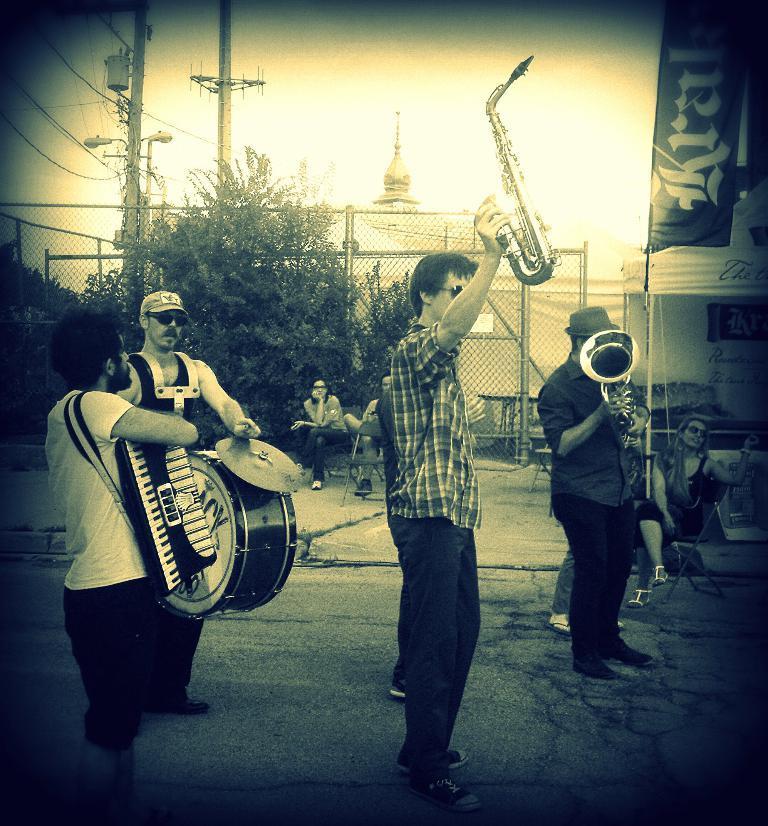In one or two sentences, can you explain what this image depicts? In this image I can see number of people where few of them are standing and holding musical instruments in their hands. In the background I can see few people are sitting. Here I can see a tree and few street lights. 